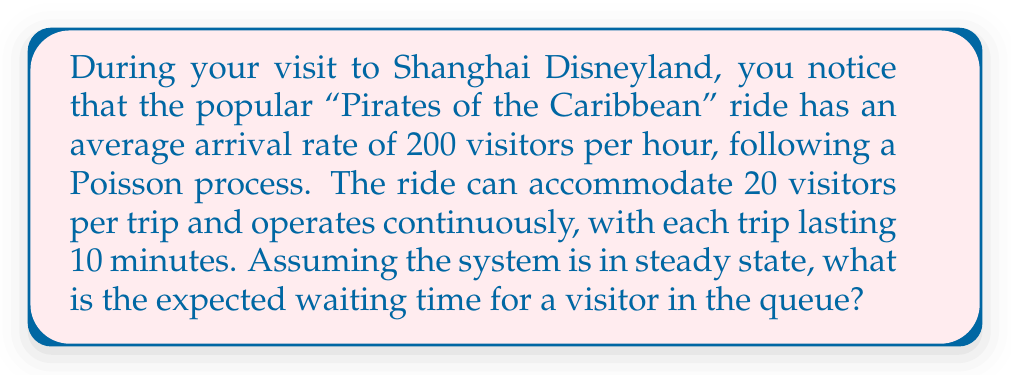Give your solution to this math problem. To solve this problem, we'll use the M/D/1 queuing model, where arrivals follow a Poisson process, service times are deterministic, and there is a single server (in this case, the ride).

Step 1: Calculate the arrival rate (λ) and service rate (μ).
λ = 200 visitors/hour
μ = (20 visitors/trip) / (10 minutes/trip) * (60 minutes/hour) = 120 visitors/hour

Step 2: Calculate the utilization factor (ρ).
ρ = λ/μ = 200/120 ≈ 1.67

Step 3: Calculate the expected number of visitors in the queue (Lq) using the Pollaczek-Khinchin formula for M/D/1 queues:
$$ L_q = \frac{\rho^2}{2(1-\rho)} $$
$$ L_q = \frac{1.67^2}{2(1-1.67)} \approx 2.32 $$

Step 4: Calculate the expected waiting time in the queue (Wq) using Little's Law:
$$ W_q = \frac{L_q}{\lambda} $$
$$ W_q = \frac{2.32}{200} \text{ hours} = 0.0116 \text{ hours} = 0.696 \text{ minutes} $$

Therefore, the expected waiting time for a visitor in the queue is approximately 0.696 minutes or 41.76 seconds.
Answer: 41.76 seconds 